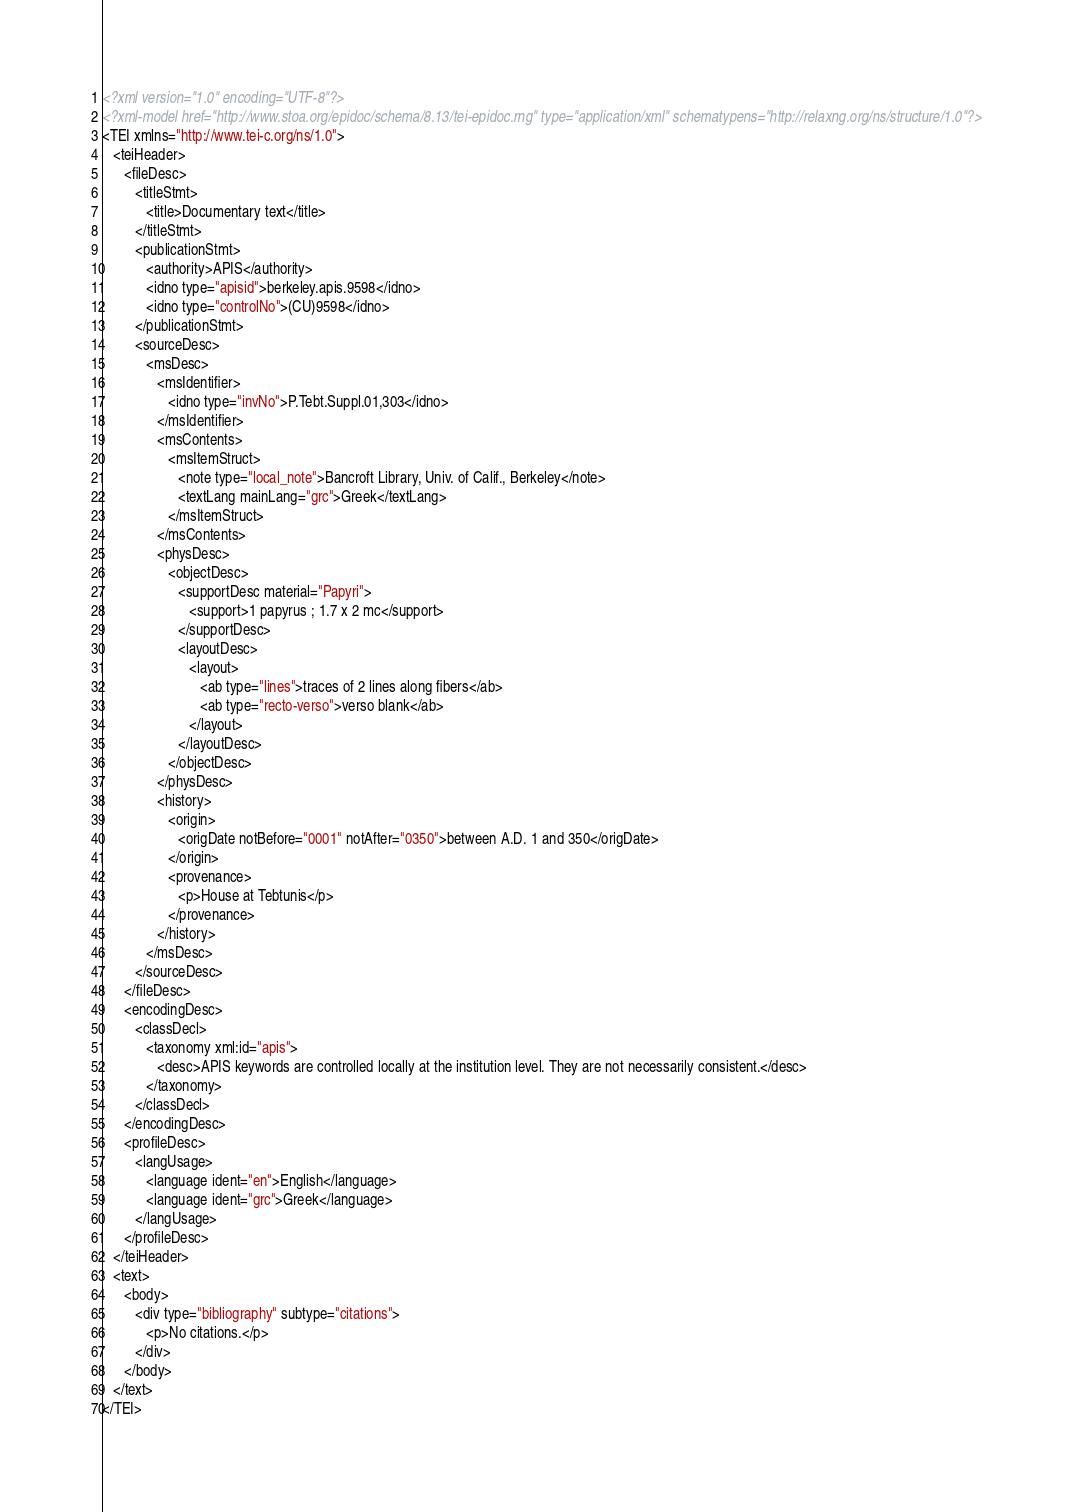Convert code to text. <code><loc_0><loc_0><loc_500><loc_500><_XML_><?xml version="1.0" encoding="UTF-8"?>
<?xml-model href="http://www.stoa.org/epidoc/schema/8.13/tei-epidoc.rng" type="application/xml" schematypens="http://relaxng.org/ns/structure/1.0"?>
<TEI xmlns="http://www.tei-c.org/ns/1.0">
   <teiHeader>
      <fileDesc>
         <titleStmt>
            <title>Documentary text</title>
         </titleStmt>
         <publicationStmt>
            <authority>APIS</authority>
            <idno type="apisid">berkeley.apis.9598</idno>
            <idno type="controlNo">(CU)9598</idno>
         </publicationStmt>
         <sourceDesc>
            <msDesc>
               <msIdentifier>
                  <idno type="invNo">P.Tebt.Suppl.01,303</idno>
               </msIdentifier>
               <msContents>
                  <msItemStruct>
                     <note type="local_note">Bancroft Library, Univ. of Calif., Berkeley</note>
                     <textLang mainLang="grc">Greek</textLang>
                  </msItemStruct>
               </msContents>
               <physDesc>
                  <objectDesc>
                     <supportDesc material="Papyri">
                        <support>1 papyrus ; 1.7 x 2 mc</support>
                     </supportDesc>
                     <layoutDesc>
                        <layout>
                           <ab type="lines">traces of 2 lines along fibers</ab>
                           <ab type="recto-verso">verso blank</ab>
                        </layout>
                     </layoutDesc>
                  </objectDesc>
               </physDesc>
               <history>
                  <origin>
                     <origDate notBefore="0001" notAfter="0350">between A.D. 1 and 350</origDate>
                  </origin>
                  <provenance>
                     <p>House at Tebtunis</p>
                  </provenance>
               </history>
            </msDesc>
         </sourceDesc>
      </fileDesc>
      <encodingDesc>
         <classDecl>
            <taxonomy xml:id="apis">
               <desc>APIS keywords are controlled locally at the institution level. They are not necessarily consistent.</desc>
            </taxonomy>
         </classDecl>
      </encodingDesc>
      <profileDesc>
         <langUsage>
            <language ident="en">English</language>
            <language ident="grc">Greek</language>
         </langUsage>
      </profileDesc>
   </teiHeader>
   <text>
      <body>
         <div type="bibliography" subtype="citations">
            <p>No citations.</p>
         </div>
      </body>
   </text>
</TEI></code> 